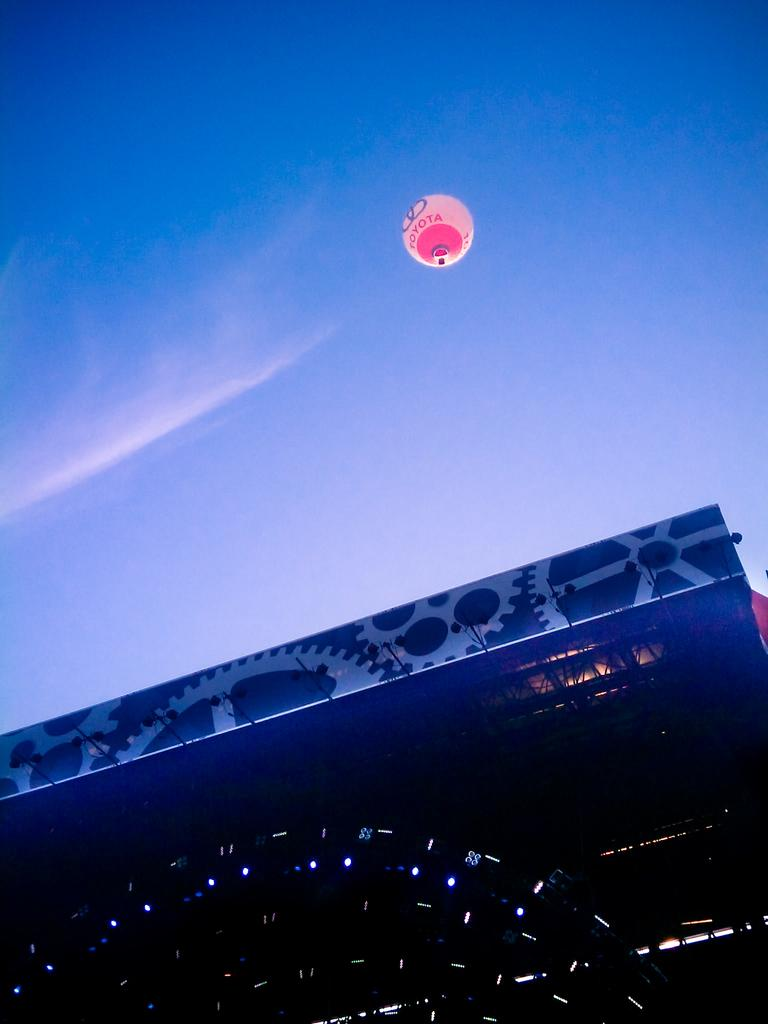What type of object in the image has lights? There is an object with lights in the image. What else can be seen in the image besides the object with lights? There is a banner and a balloon with text on it in the image. What is the condition of the sky in the image? The sky is visible in the image. Reasoning: Let' Let's think step by step in order to produce the conversation. We start by identifying the main subjects and objects in the image based on the provided facts. We then formulate questions that focus on the characteristics of these subjects and objects, ensuring that each question can be answered definitively with the information given. We avoid yes/no questions and ensure that the language is simple and clear. Absurd Question/Answer: How does the yak contribute to the decorations in the image? There is no yak present in the image; it only features an object with lights, a banner, and a balloon with text on it. How does the yak contribute to the decorations in the image? There is no yak present in the image; it only features an object with lights, a banner, and a balloon with text on it. 